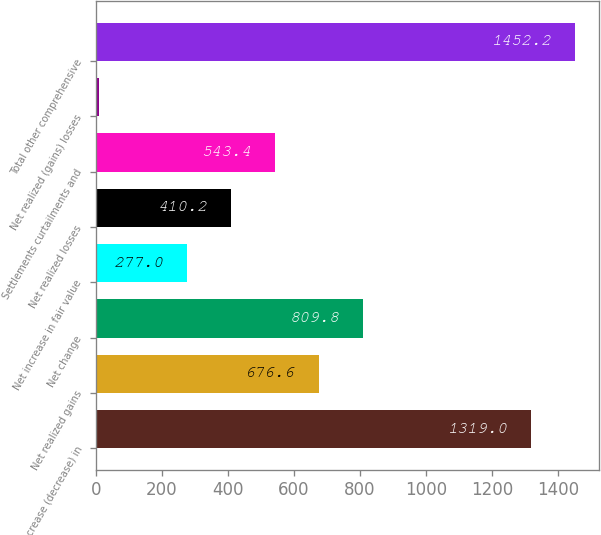Convert chart. <chart><loc_0><loc_0><loc_500><loc_500><bar_chart><fcel>Net increase (decrease) in<fcel>Net realized gains<fcel>Net change<fcel>Net increase in fair value<fcel>Net realized losses<fcel>Settlements curtailments and<fcel>Net realized (gains) losses<fcel>Total other comprehensive<nl><fcel>1319<fcel>676.6<fcel>809.8<fcel>277<fcel>410.2<fcel>543.4<fcel>10<fcel>1452.2<nl></chart> 